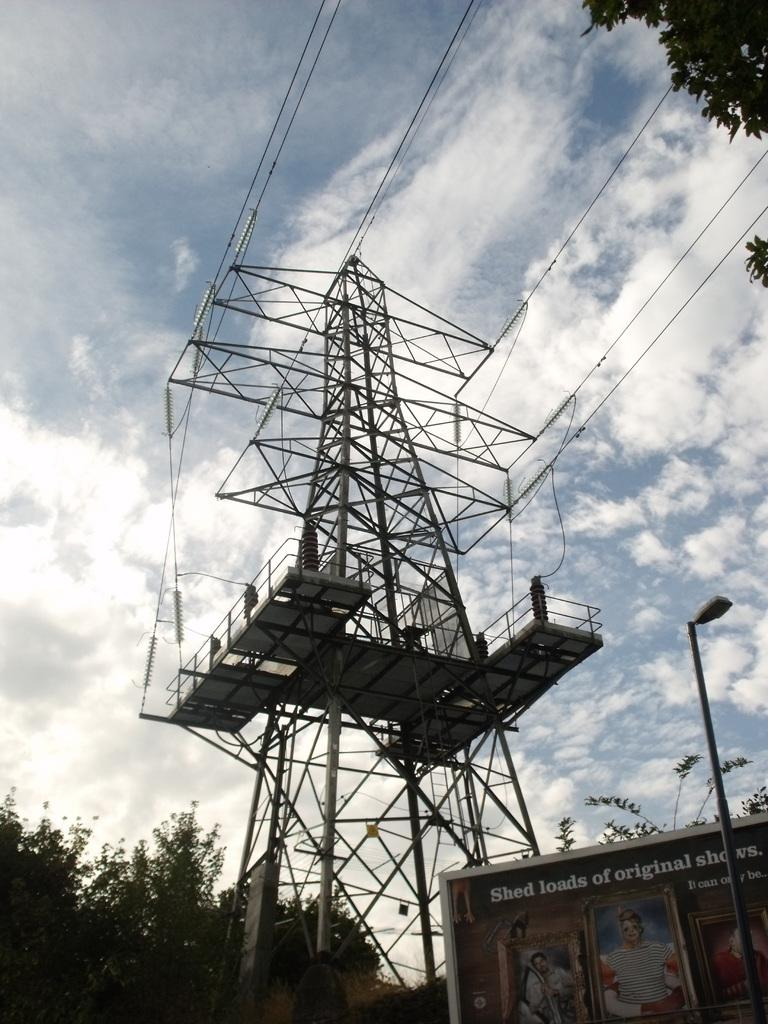What is the main structure in the image? There is a tower in the image. What can be seen on the left side of the image? There are trees on the left side of the image. What is visible in the sky in the background of the image? There are clouds visible in the sky in the background of the image. Can you tell me who won the argument in the image? There is no argument present in the image; it features a tower, trees, and clouds. What type of bulb is used to light up the tower in the image? There is no information about the lighting of the tower in the image, and no bulb is visible. 